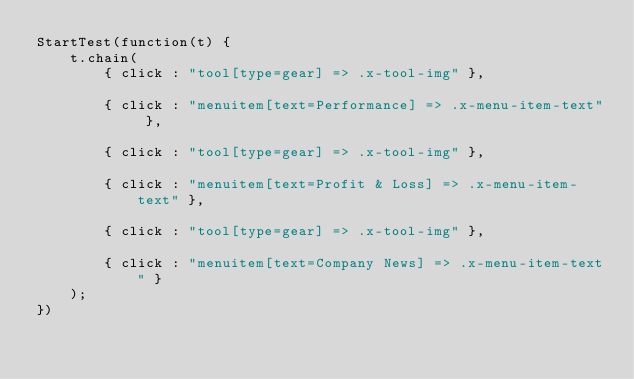Convert code to text. <code><loc_0><loc_0><loc_500><loc_500><_JavaScript_>StartTest(function(t) {
    t.chain(
        { click : "tool[type=gear] => .x-tool-img" },

        { click : "menuitem[text=Performance] => .x-menu-item-text" },

        { click : "tool[type=gear] => .x-tool-img" },

        { click : "menuitem[text=Profit & Loss] => .x-menu-item-text" },

        { click : "tool[type=gear] => .x-tool-img" },

        { click : "menuitem[text=Company News] => .x-menu-item-text" }
    );
})    
</code> 